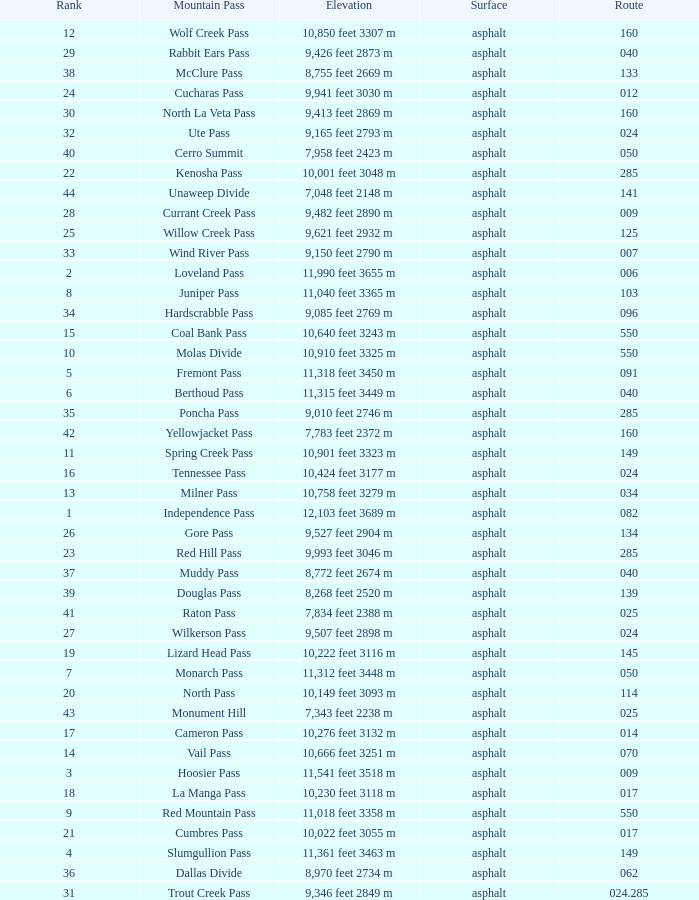Which mountain pass has a height of 10,001 feet 3048 m? Kenosha Pass. Can you give me this table as a dict? {'header': ['Rank', 'Mountain Pass', 'Elevation', 'Surface', 'Route'], 'rows': [['12', 'Wolf Creek Pass', '10,850 feet 3307 m', 'asphalt', '160'], ['29', 'Rabbit Ears Pass', '9,426 feet 2873 m', 'asphalt', '040'], ['38', 'McClure Pass', '8,755 feet 2669 m', 'asphalt', '133'], ['24', 'Cucharas Pass', '9,941 feet 3030 m', 'asphalt', '012'], ['30', 'North La Veta Pass', '9,413 feet 2869 m', 'asphalt', '160'], ['32', 'Ute Pass', '9,165 feet 2793 m', 'asphalt', '024'], ['40', 'Cerro Summit', '7,958 feet 2423 m', 'asphalt', '050'], ['22', 'Kenosha Pass', '10,001 feet 3048 m', 'asphalt', '285'], ['44', 'Unaweep Divide', '7,048 feet 2148 m', 'asphalt', '141'], ['28', 'Currant Creek Pass', '9,482 feet 2890 m', 'asphalt', '009'], ['25', 'Willow Creek Pass', '9,621 feet 2932 m', 'asphalt', '125'], ['33', 'Wind River Pass', '9,150 feet 2790 m', 'asphalt', '007'], ['2', 'Loveland Pass', '11,990 feet 3655 m', 'asphalt', '006'], ['8', 'Juniper Pass', '11,040 feet 3365 m', 'asphalt', '103'], ['34', 'Hardscrabble Pass', '9,085 feet 2769 m', 'asphalt', '096'], ['15', 'Coal Bank Pass', '10,640 feet 3243 m', 'asphalt', '550'], ['10', 'Molas Divide', '10,910 feet 3325 m', 'asphalt', '550'], ['5', 'Fremont Pass', '11,318 feet 3450 m', 'asphalt', '091'], ['6', 'Berthoud Pass', '11,315 feet 3449 m', 'asphalt', '040'], ['35', 'Poncha Pass', '9,010 feet 2746 m', 'asphalt', '285'], ['42', 'Yellowjacket Pass', '7,783 feet 2372 m', 'asphalt', '160'], ['11', 'Spring Creek Pass', '10,901 feet 3323 m', 'asphalt', '149'], ['16', 'Tennessee Pass', '10,424 feet 3177 m', 'asphalt', '024'], ['13', 'Milner Pass', '10,758 feet 3279 m', 'asphalt', '034'], ['1', 'Independence Pass', '12,103 feet 3689 m', 'asphalt', '082'], ['26', 'Gore Pass', '9,527 feet 2904 m', 'asphalt', '134'], ['23', 'Red Hill Pass', '9,993 feet 3046 m', 'asphalt', '285'], ['37', 'Muddy Pass', '8,772 feet 2674 m', 'asphalt', '040'], ['39', 'Douglas Pass', '8,268 feet 2520 m', 'asphalt', '139'], ['41', 'Raton Pass', '7,834 feet 2388 m', 'asphalt', '025'], ['27', 'Wilkerson Pass', '9,507 feet 2898 m', 'asphalt', '024'], ['19', 'Lizard Head Pass', '10,222 feet 3116 m', 'asphalt', '145'], ['7', 'Monarch Pass', '11,312 feet 3448 m', 'asphalt', '050'], ['20', 'North Pass', '10,149 feet 3093 m', 'asphalt', '114'], ['43', 'Monument Hill', '7,343 feet 2238 m', 'asphalt', '025'], ['17', 'Cameron Pass', '10,276 feet 3132 m', 'asphalt', '014'], ['14', 'Vail Pass', '10,666 feet 3251 m', 'asphalt', '070'], ['3', 'Hoosier Pass', '11,541 feet 3518 m', 'asphalt', '009'], ['18', 'La Manga Pass', '10,230 feet 3118 m', 'asphalt', '017'], ['9', 'Red Mountain Pass', '11,018 feet 3358 m', 'asphalt', '550'], ['21', 'Cumbres Pass', '10,022 feet 3055 m', 'asphalt', '017'], ['4', 'Slumgullion Pass', '11,361 feet 3463 m', 'asphalt', '149'], ['36', 'Dallas Divide', '8,970 feet 2734 m', 'asphalt', '062'], ['31', 'Trout Creek Pass', '9,346 feet 2849 m', 'asphalt', '024.285']]} 